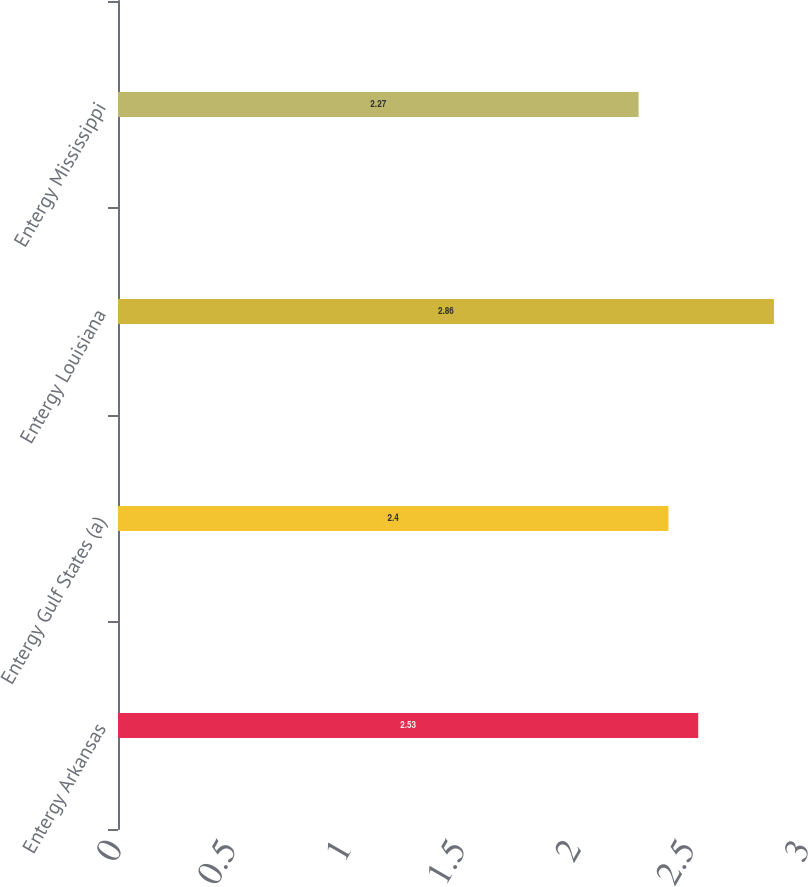<chart> <loc_0><loc_0><loc_500><loc_500><bar_chart><fcel>Entergy Arkansas<fcel>Entergy Gulf States (a)<fcel>Entergy Louisiana<fcel>Entergy Mississippi<nl><fcel>2.53<fcel>2.4<fcel>2.86<fcel>2.27<nl></chart> 